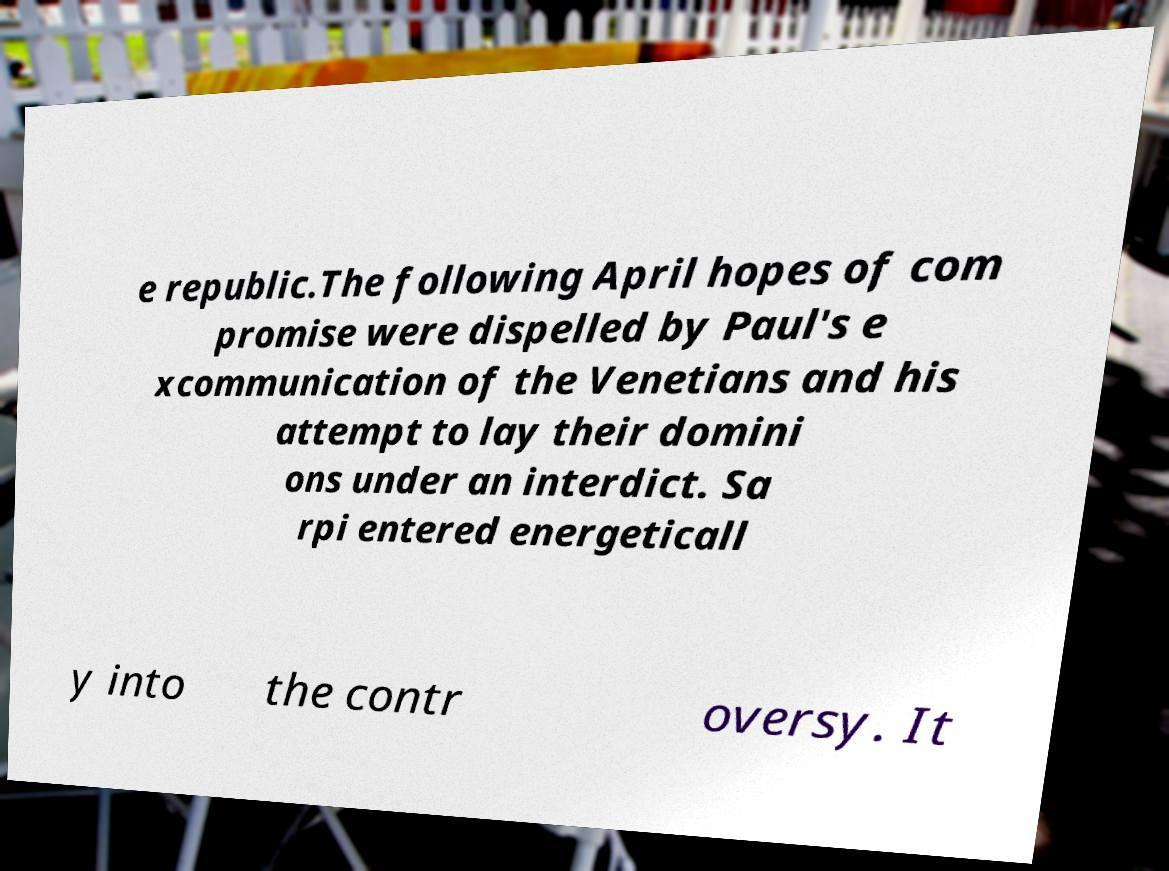I need the written content from this picture converted into text. Can you do that? e republic.The following April hopes of com promise were dispelled by Paul's e xcommunication of the Venetians and his attempt to lay their domini ons under an interdict. Sa rpi entered energeticall y into the contr oversy. It 